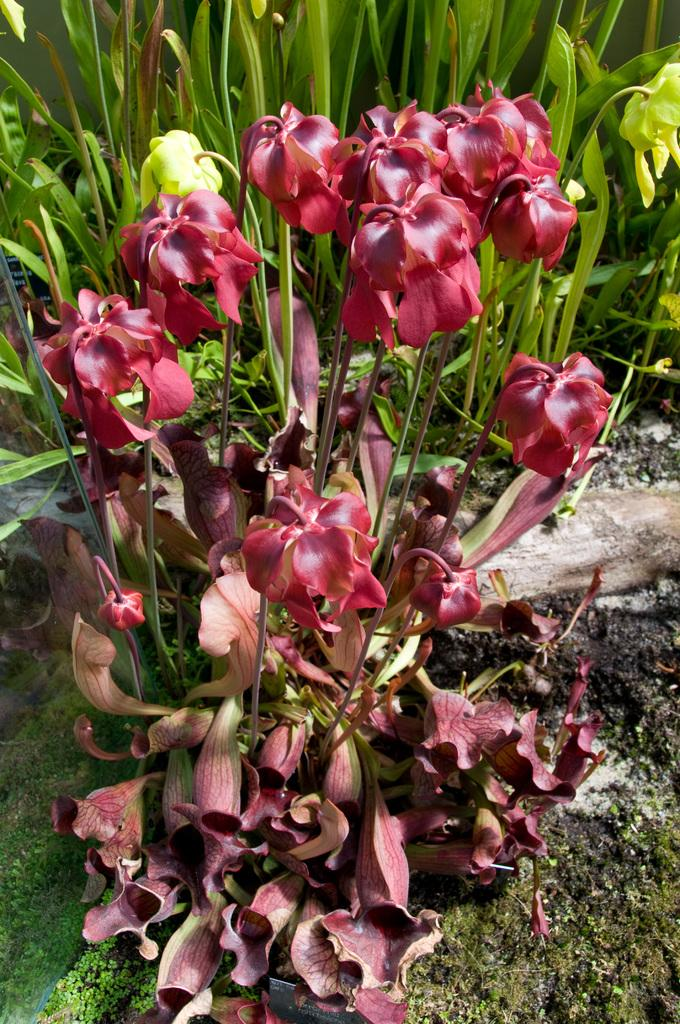What is the main subject in the middle of the image? There is a flower plant in the middle of the image. What can be seen in the background of the image? There are green leaves in the background of the image. What type of vegetation is present on the ground in the image? There is grass on the ground in the image. Can you tell me how many judges are present in the image? There are no judges present in the image; it features a flower plant, green leaves, and grass. What type of crown can be seen on the flower plant in the image? There is no crown present on the flower plant in the image. 